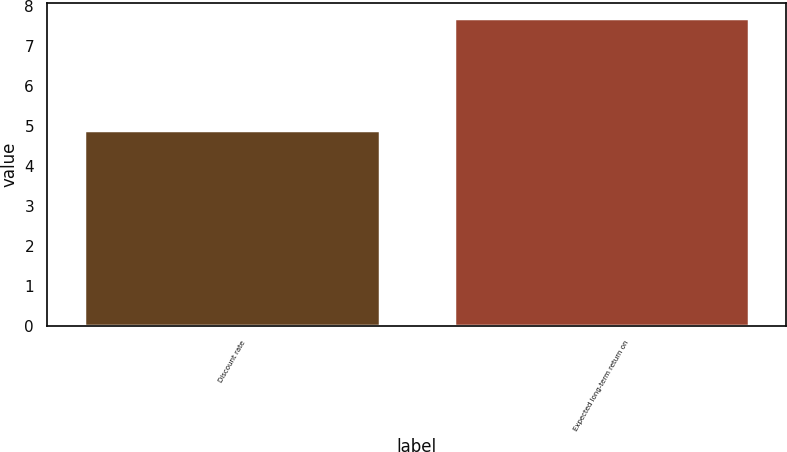Convert chart. <chart><loc_0><loc_0><loc_500><loc_500><bar_chart><fcel>Discount rate<fcel>Expected long-term return on<nl><fcel>4.9<fcel>7.7<nl></chart> 